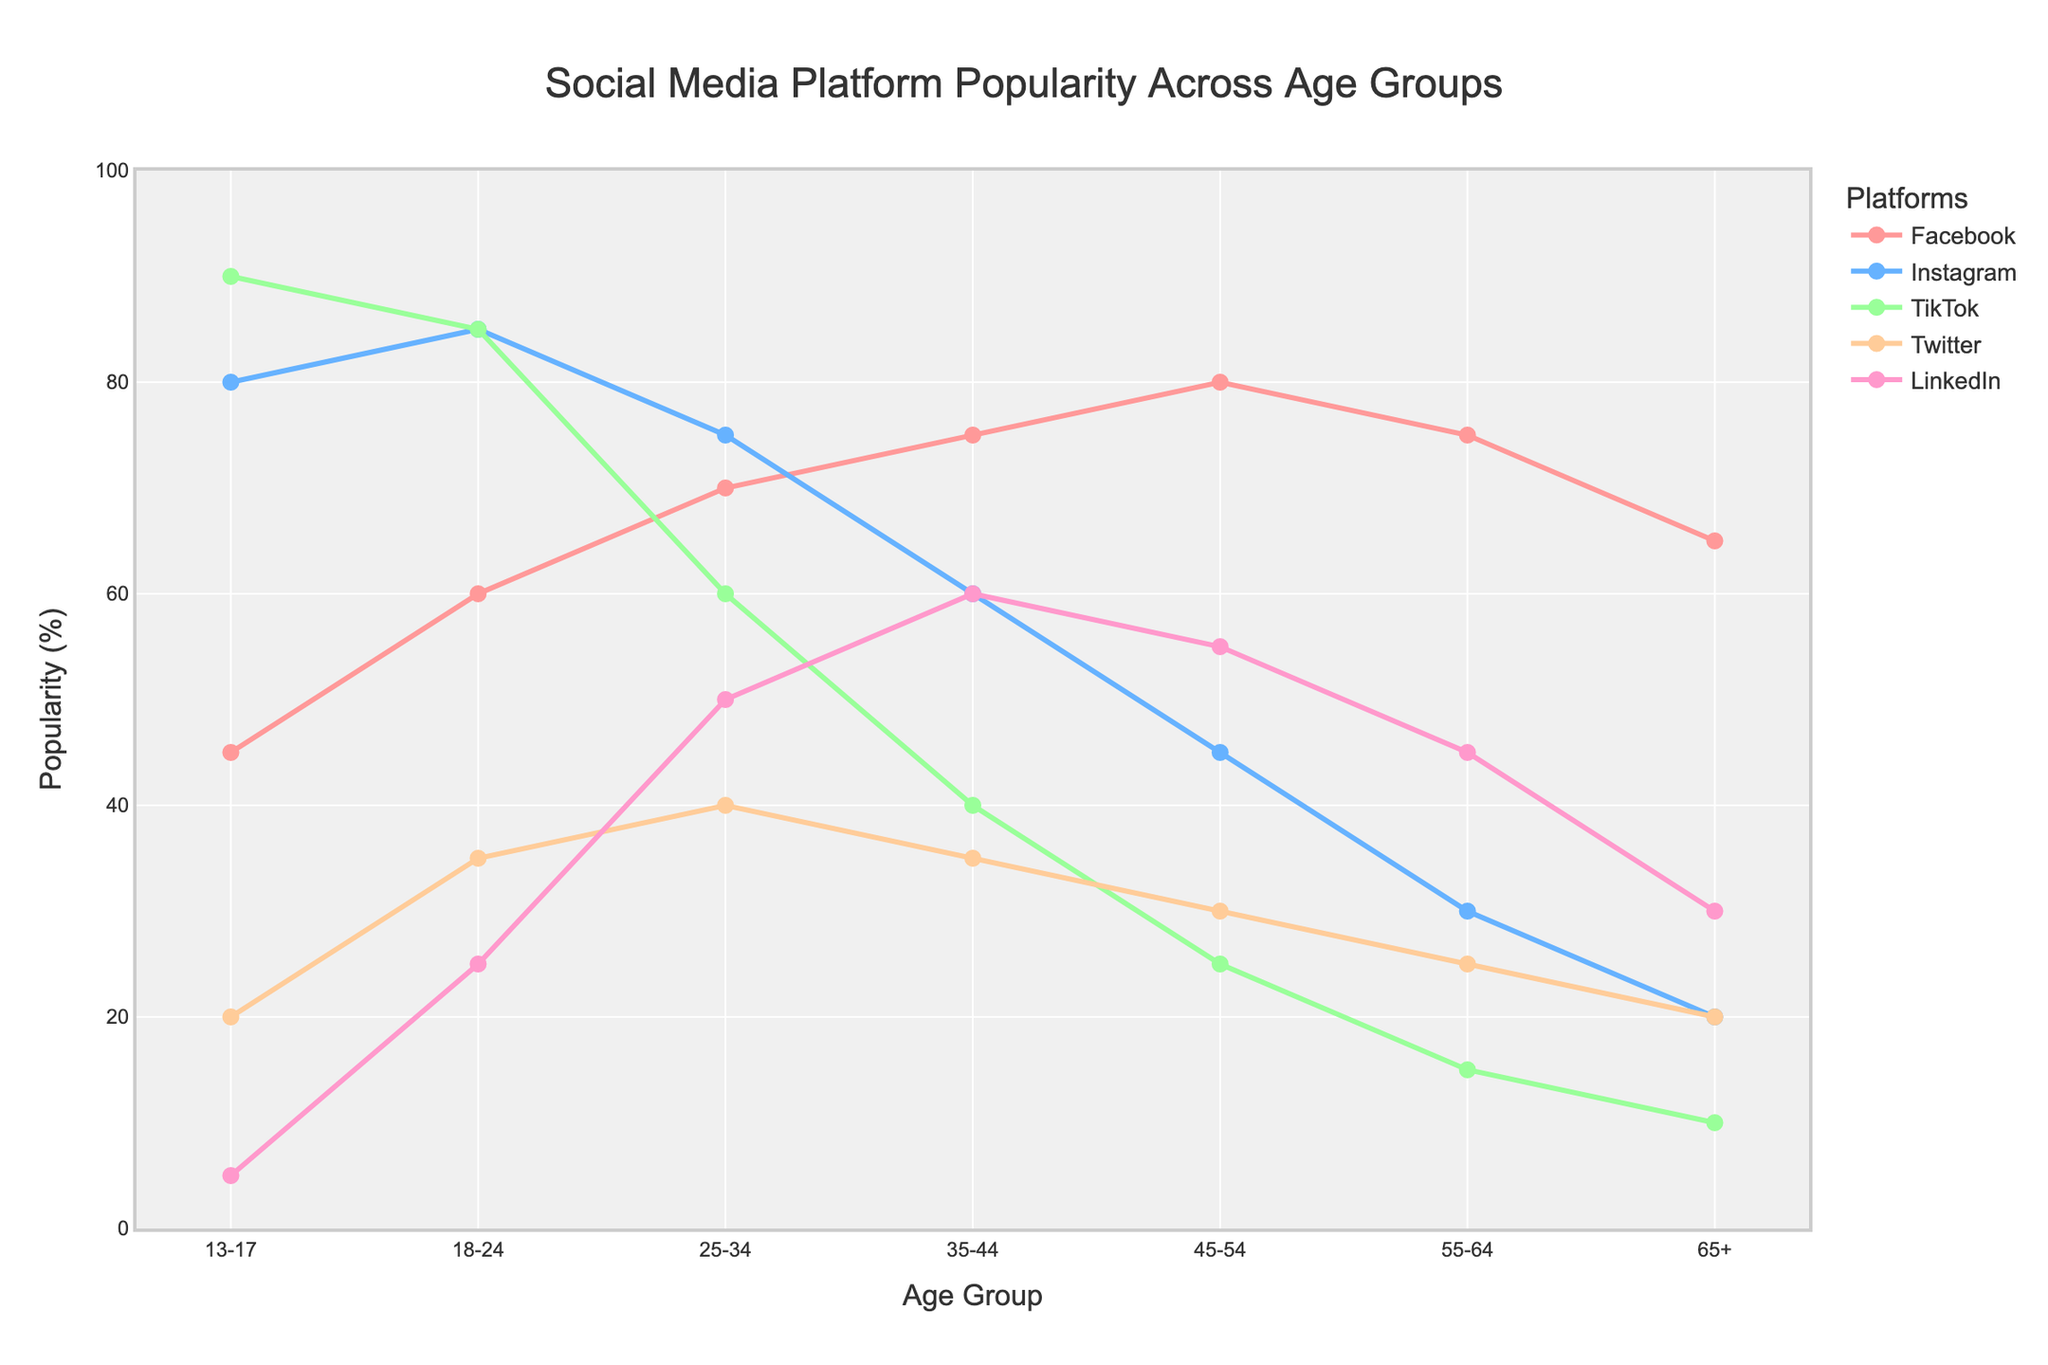What is the age group with the highest popularity for TikTok? To find the age group with the highest popularity for TikTok, you need to identify the maximum value on the TikTok line and then find the corresponding age group. The highest value for TikTok is 90%, which corresponds to the 13-17 age group.
Answer: 13-17 How does the popularity of Facebook change from the 18-24 age group to the 45-54 age group? Observe the Facebook line for the values corresponding to the 18-24 and the 45-54 age groups. The popularity of Facebook in the 18-24 age group is 60%, and in the 45-54 age group, it is 80%. Thus, the popularity increases by 20%.
Answer: It increases by 20% Which platform is most popular among the 25-34 age group? Look at the data points for each platform in the 25-34 age group. The highest point corresponds to Facebook, with a value of 70%.
Answer: Facebook Compare the popularity of LinkedIn for the age groups 18-24 and 65+. Check the values for LinkedIn in the age groups 18-24 and 65+. The popularity for LinkedIn in the 18-24 age group is 25%, and in the 65+ age group, it is 30%.
Answer: LinkedIn is more popular in the 65+ age group What is the total popularity percentage for Instagram across all age groups? To find the total popularity percentage for Instagram, sum the values across all the age groups: 80 + 85 + 75 + 60 + 45 + 30 + 20. This equals 395%.
Answer: 395% Which age group has the least popularity for Twitter, and what is the value? The least popularity for Twitter is represented by the smallest value on the Twitter line. The smallest value is 20%, and it corresponds to both the 13-17 and 65+ age groups.
Answer: 13-17 and 65+, 20% What is the trend of Instagram's popularity as the age group increases from 13-17 to 65+? Observe the Instagram line from the 13-17 age group to the 65+ age group. It decreases consistently from 80% to 20%.
Answer: It decreases consistently Which platform shows the most significant drop in popularity as age increases from 13-17 to 65+, and what is the value of this drop? Calculate the difference in values from 13-17 to 65+ for each platform. TikTok drops from 90% to 10%, which is a 80% drop, the most significant.
Answer: TikTok, 80% For the age group 55-64, which platform is second most popular? Look at the values for each platform in the 55-64 age group and identify the second highest value, which corresponds to Facebook at 75%.
Answer: Facebook Between the 25-34 and 35-44 age groups, which platform shows an increase in popularity, and by how much? Compare the values for each platform between the 25-34 and 35-44 age groups. LinkedIn shows an increase from 50% to 60%, a difference of 10%.
Answer: LinkedIn, 10% increase 